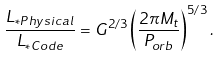Convert formula to latex. <formula><loc_0><loc_0><loc_500><loc_500>\frac { L _ { * P h y s i c a l } } { L _ { * C o d e } } = G ^ { 2 / 3 } \left ( \frac { 2 \pi M _ { t } } { P _ { o r b } } \right ) ^ { 5 / 3 } .</formula> 